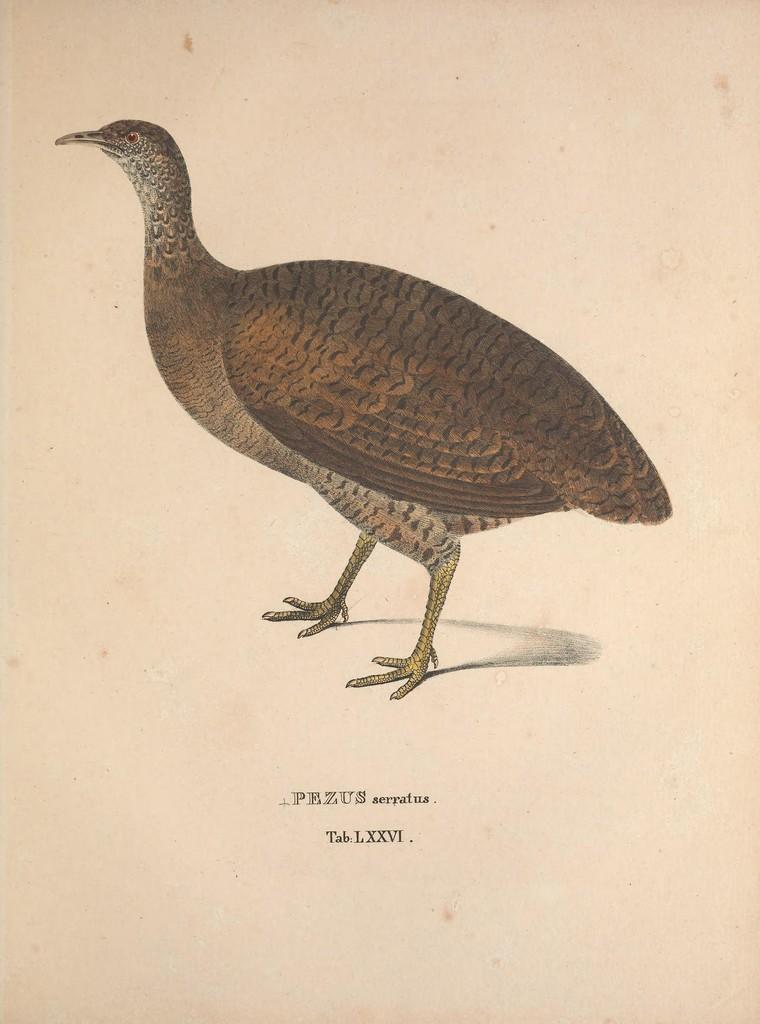In one or two sentences, can you explain what this image depicts? In this picture I can see the drawing of the bird on the paper. I can see text on it. 